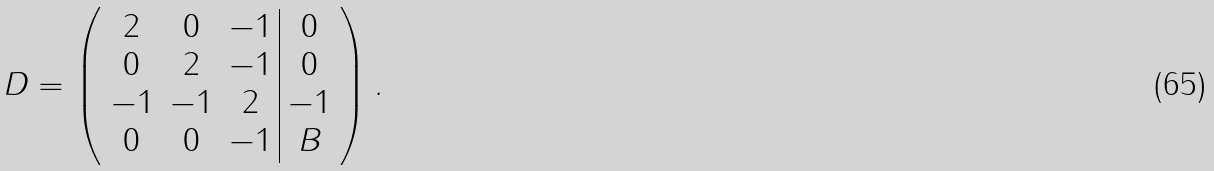<formula> <loc_0><loc_0><loc_500><loc_500>D = \left ( \begin{array} { c c c | c c } 2 & 0 & - 1 & 0 \\ 0 & 2 & - 1 & 0 \\ - 1 & - 1 & 2 & - 1 \\ 0 & 0 & - 1 & B \\ \end{array} \right ) .</formula> 